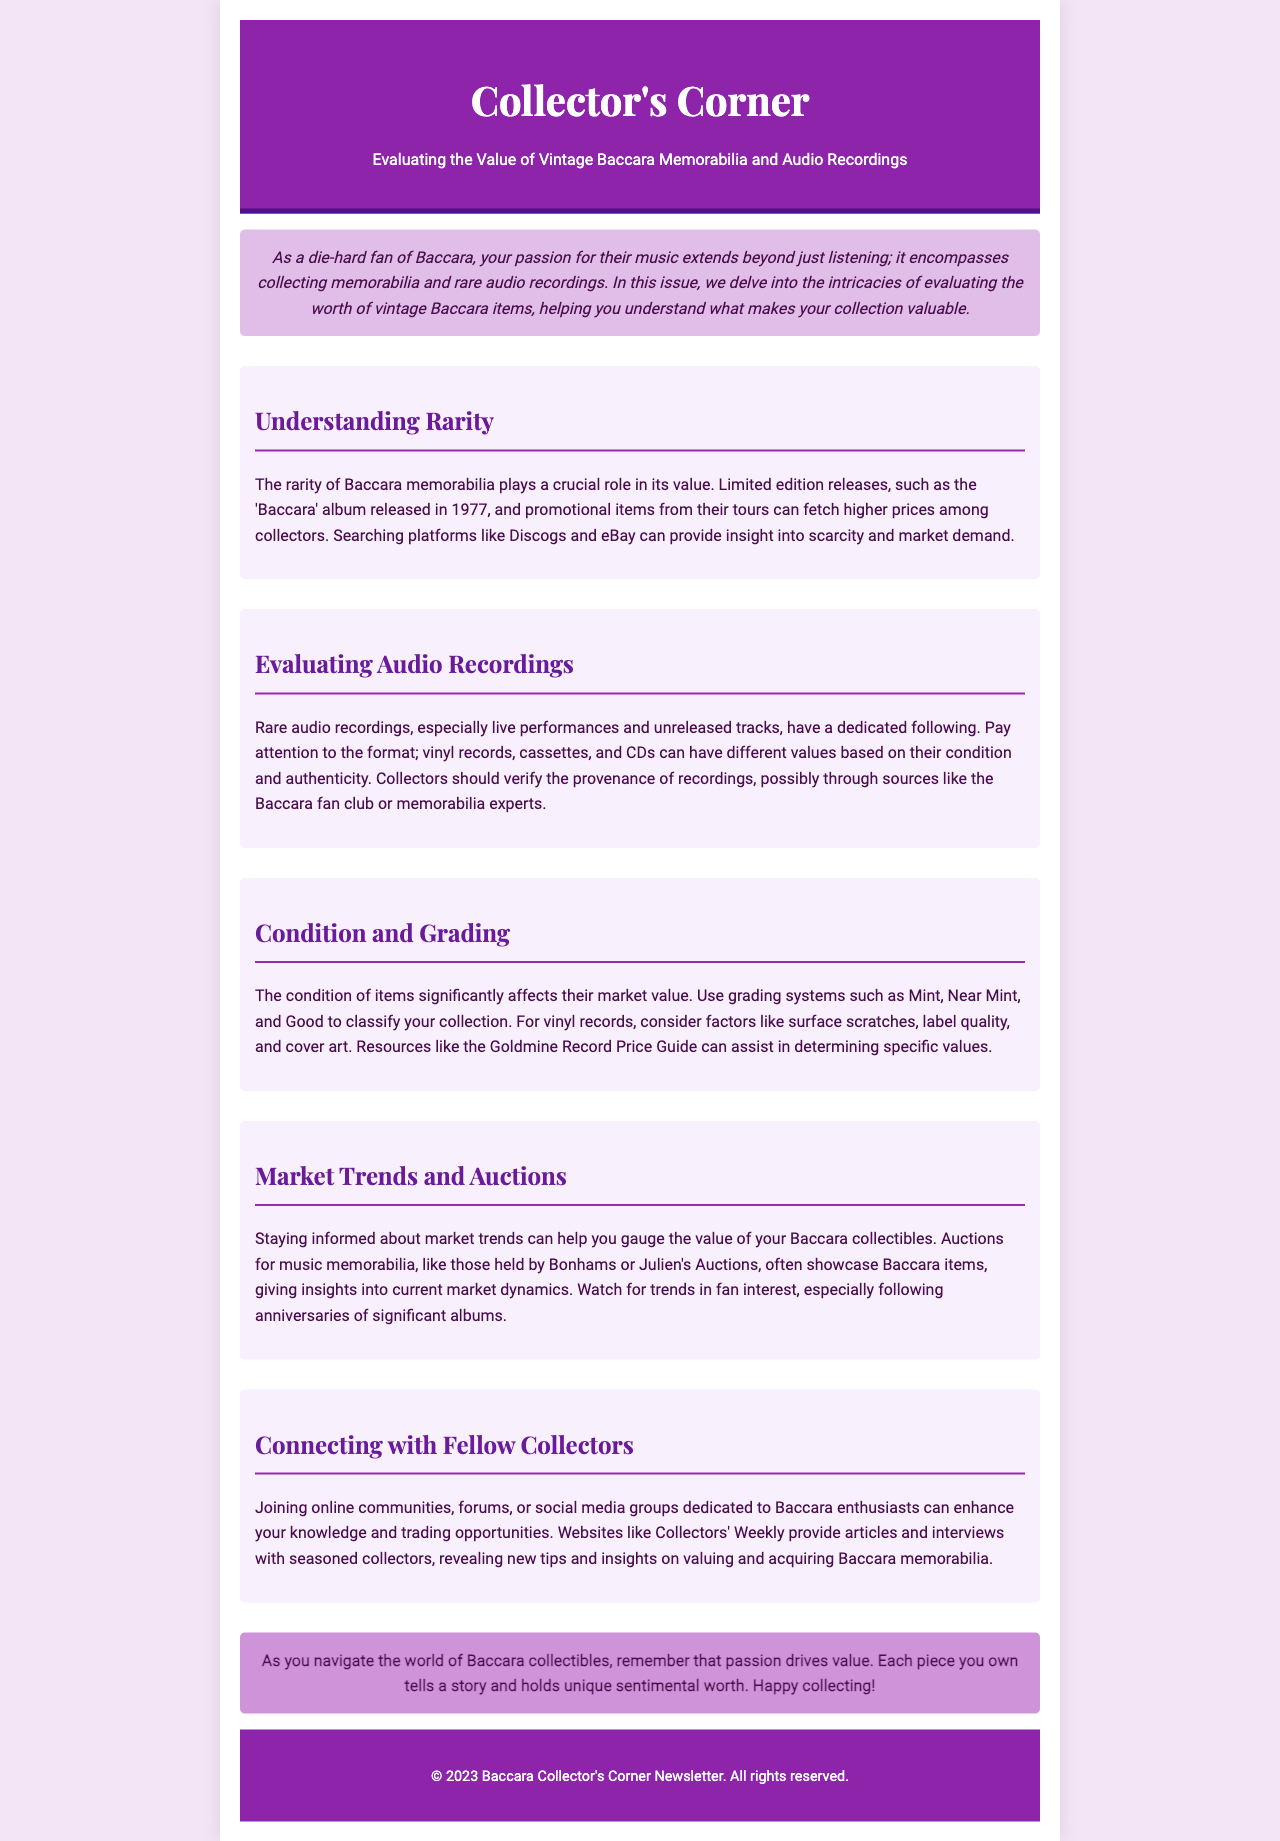What is the publication year of the 'Baccara' album? The document states that the 'Baccara' album was released in 1977.
Answer: 1977 What color is the background of the newsletter? The document describes the background color as #f3e5f5 in CSS, which translates to a light purple shade.
Answer: Light purple What does the section titled "Evaluating Audio Recordings" emphasize? This section focuses on rare audio recordings, their formats, and the importance of verifying authenticity.
Answer: Authenticity Which grading system is mentioned for evaluating condition? The grading system mentioned includes Mint, Near Mint, and Good.
Answer: Mint, Near Mint, and Good What should collectors pay attention to regarding audio formats? The document mentions that vinyl records, cassettes, and CDs can have different values based on condition and authenticity.
Answer: Condition and authenticity What type of items are showcased in auctions mentioned in the document? Auctions often showcase music memorabilia, specifically items related to Baccara.
Answer: Music memorabilia Which resource is suggested for determining specific values of vinyl records? The document refers to the Goldmine Record Price Guide as a helpful resource for determining values.
Answer: Goldmine Record Price Guide What is the primary motivation behind the value of collectibles according to the conclusion? The conclusion states that passion drives value in collectibles.
Answer: Passion 